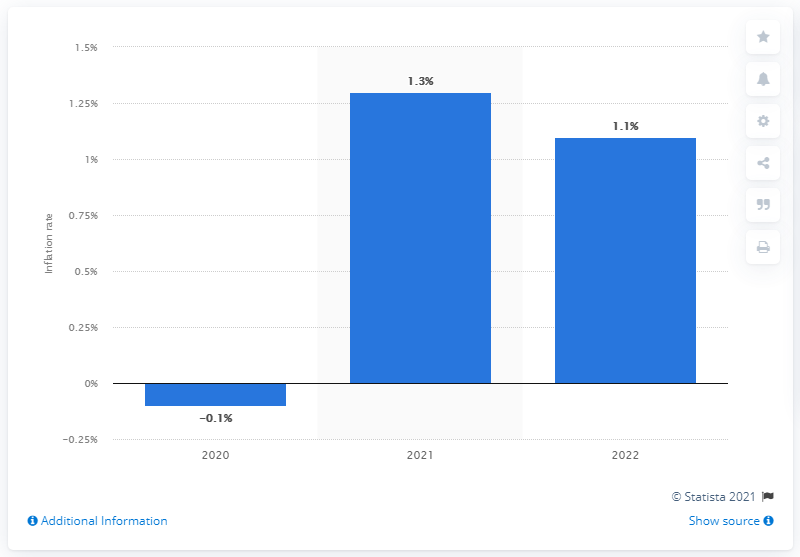Give some essential details in this illustration. The inflation rate in 2022 was 1.1%. Consumer price inflation in Italy is expected to increase by 1.3% in 2021, according to data published in May 2021. 